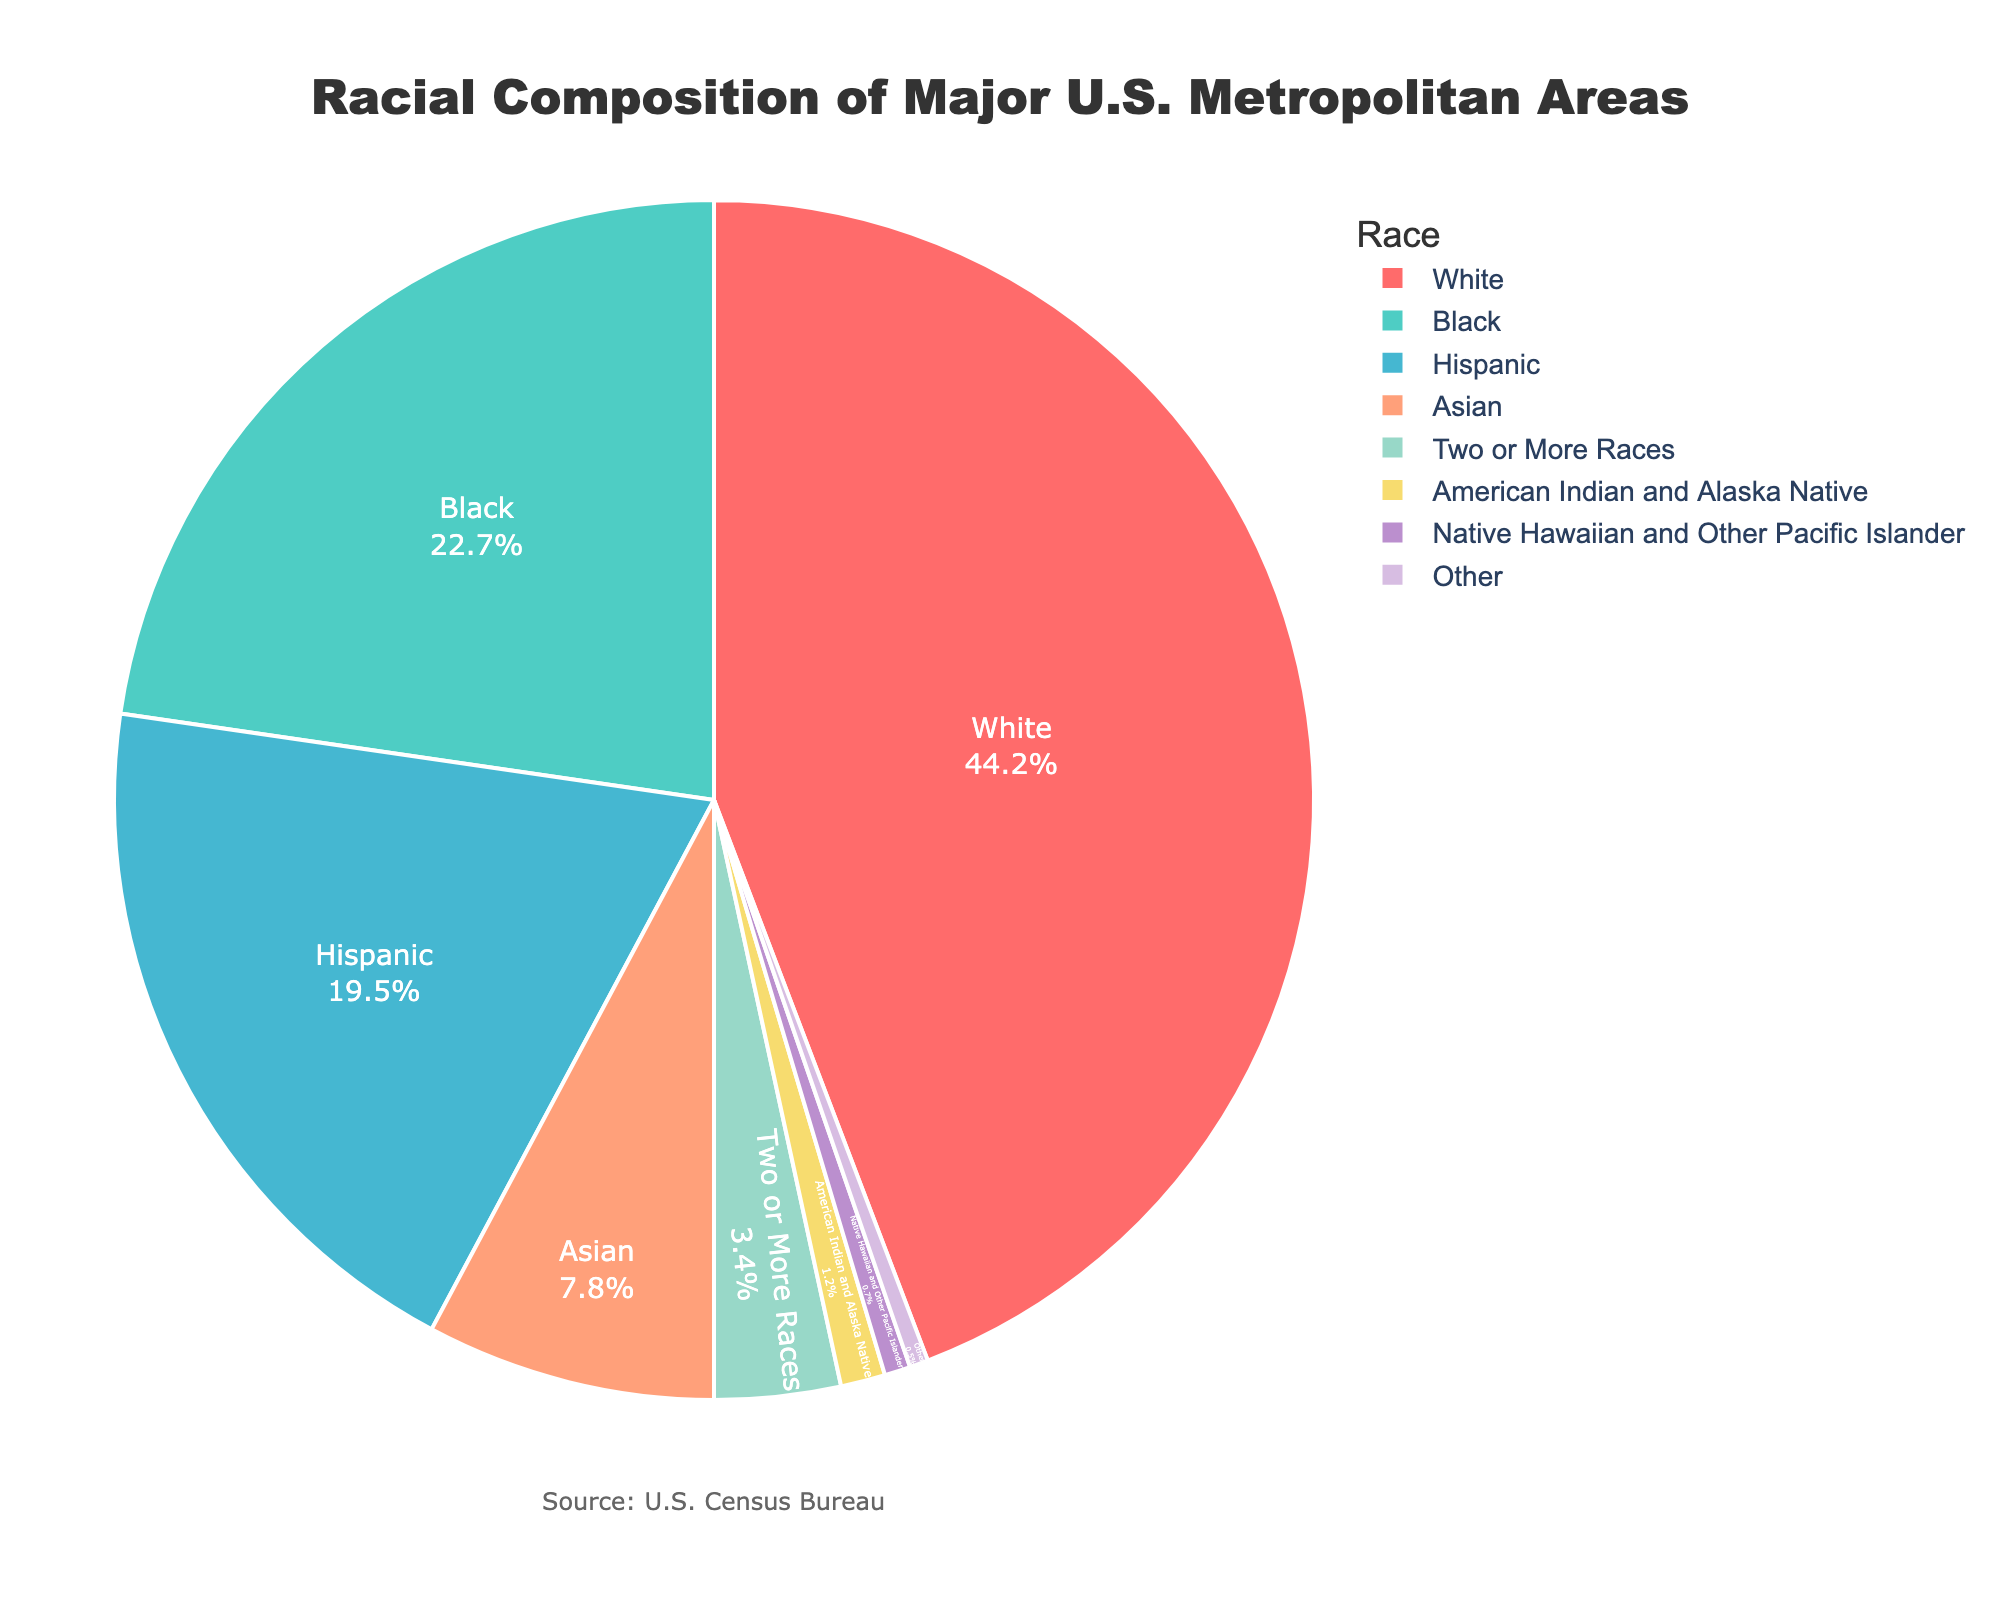Which racial group has the highest percentage in major U.S. metropolitan areas? The pie chart shows slices representing various racial groups, and the largest slice corresponds to the White population.
Answer: White Compare the percentage of Hispanic and Asian populations. Which is higher? The chart shows the Hispanic population is 19.5% and the Asian population is 7.8%. Hispanic has a higher percentage.
Answer: Hispanic What is the combined percentage of racial groups other than White and Black? Adding the percentages of all other groups: 19.5 (Hispanic) + 7.8 (Asian) + 3.4 (Two or More Races) + 1.2 (American Indian and Alaska Native) + 0.7 (Native Hawaiian and Other Pacific Islander) + 0.5 (Other) = 33.1%.
Answer: 33.1% Which two racial groups have the closest percentages? The chart shows the percentages as 0.7% for Native Hawaiian and Other Pacific Islander and 0.5% for Other, making these the closest in percentage.
Answer: Native Hawaiian and Other Pacific Islander, Other What is the sum of the percentages of Black and Hispanic populations? Adding the percentages from the chart: 22.7% (Black) + 19.5% (Hispanic) = 42.2%.
Answer: 42.2% Which racial group occupies the smallest portion of the pie chart? The smallest slice on the chart corresponds to the "Other" category at 0.5%.
Answer: Other Is the percentage of the Two or More Races category greater than the American Indian and Alaska Native category? The Two or More Races category is 3.4%, while the American Indian and Alaska Native category is 1.2%. 3.4% is greater than 1.2%.
Answer: Yes What is the difference in percentage between the Asian population and White population? The chart shows the Asian population at 7.8% and the White population at 44.2%. The difference is 44.2% - 7.8% = 36.4%.
Answer: 36.4% What color represents the Black population in the chart? The pie chart shows different colors for each racial group. The Black population is represented by a turquoise color.
Answer: Turquoise If you combine the percentages of the Native Hawaiian and Other Pacific Islander and Other categories, what would be the total? Adding the percentages: 0.7% (Native Hawaiian and Other Pacific Islander) + 0.5% (Other) = 1.2%.
Answer: 1.2% 